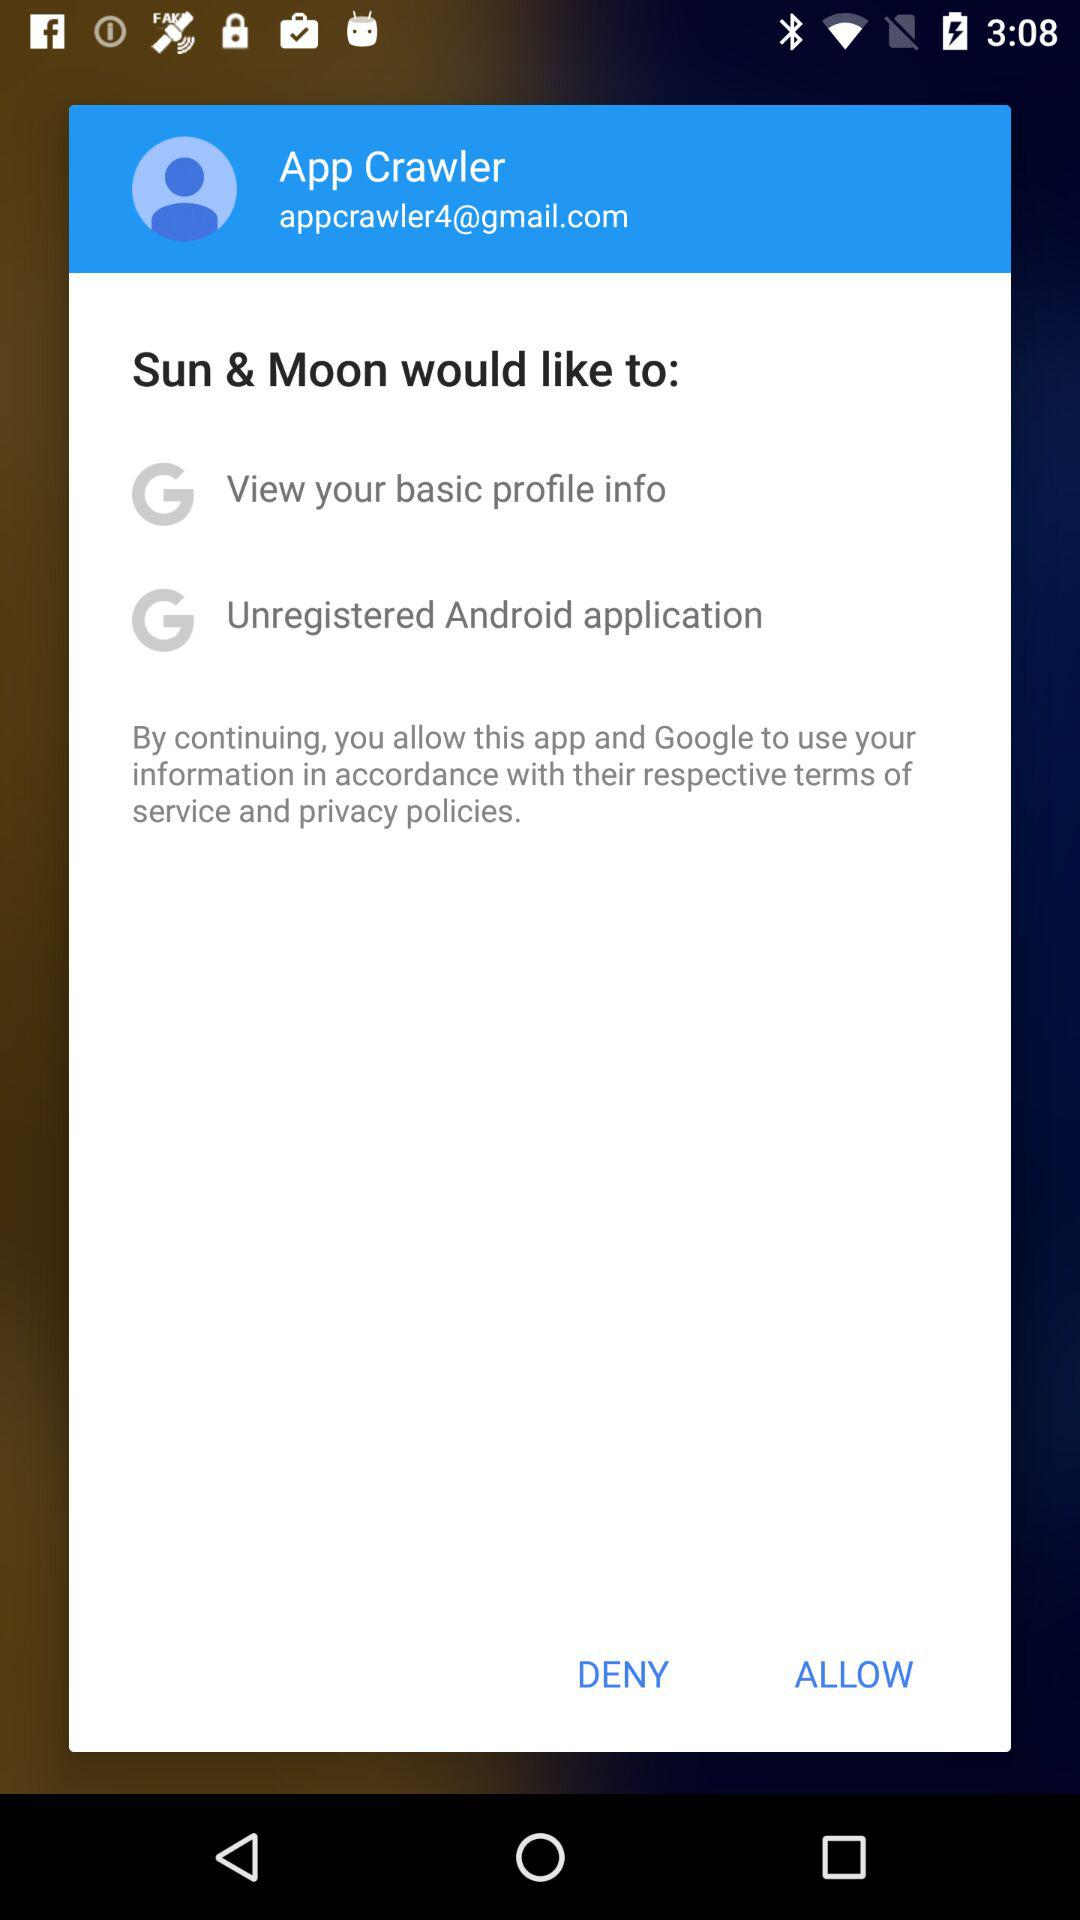What is the email address? The email address is appcrawler4@gmail.com. 